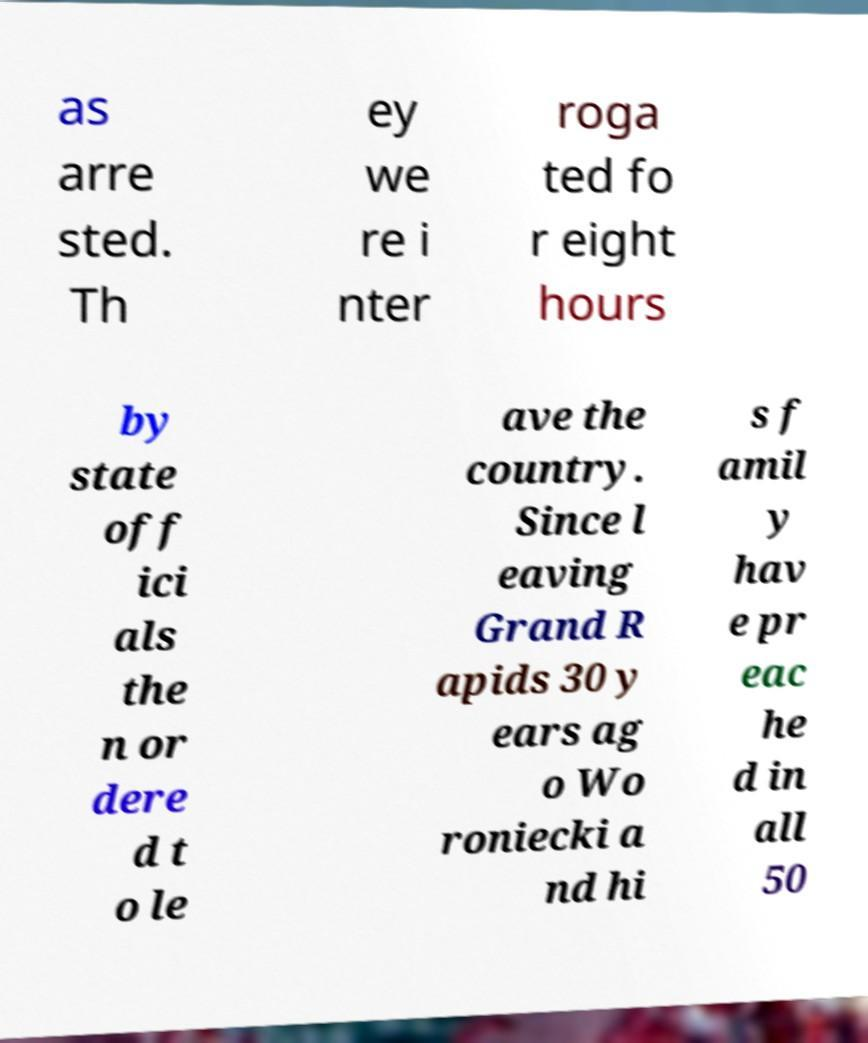Could you extract and type out the text from this image? as arre sted. Th ey we re i nter roga ted fo r eight hours by state off ici als the n or dere d t o le ave the country. Since l eaving Grand R apids 30 y ears ag o Wo roniecki a nd hi s f amil y hav e pr eac he d in all 50 